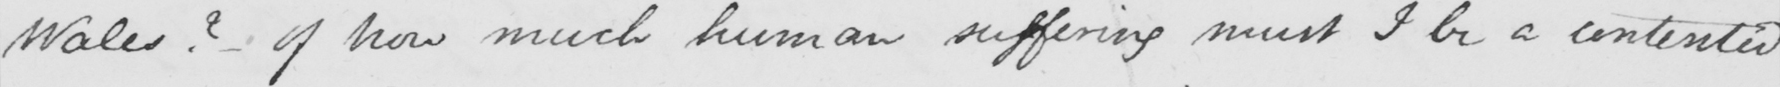Please provide the text content of this handwritten line. Wales ?   _  of how much human suffering must I be a contented 